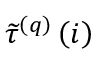<formula> <loc_0><loc_0><loc_500><loc_500>\widetilde { \tau } ^ { \left ( q \right ) } \left ( i \right )</formula> 